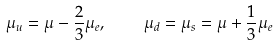Convert formula to latex. <formula><loc_0><loc_0><loc_500><loc_500>\mu _ { u } = \mu - \frac { 2 } { 3 } \mu _ { e } , \quad \mu _ { d } = \mu _ { s } = \mu + \frac { 1 } { 3 } \mu _ { e }</formula> 